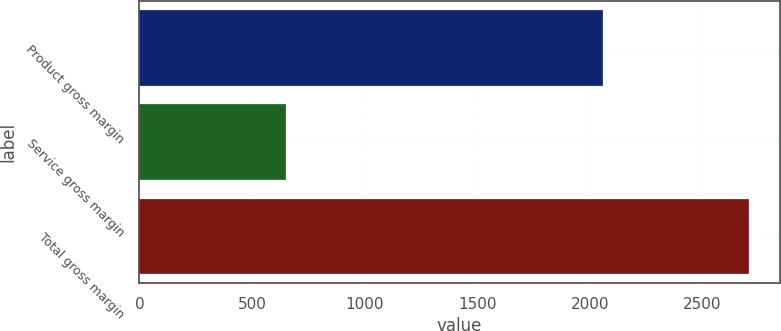Convert chart to OTSL. <chart><loc_0><loc_0><loc_500><loc_500><bar_chart><fcel>Product gross margin<fcel>Service gross margin<fcel>Total gross margin<nl><fcel>2058.1<fcel>650.7<fcel>2708.8<nl></chart> 